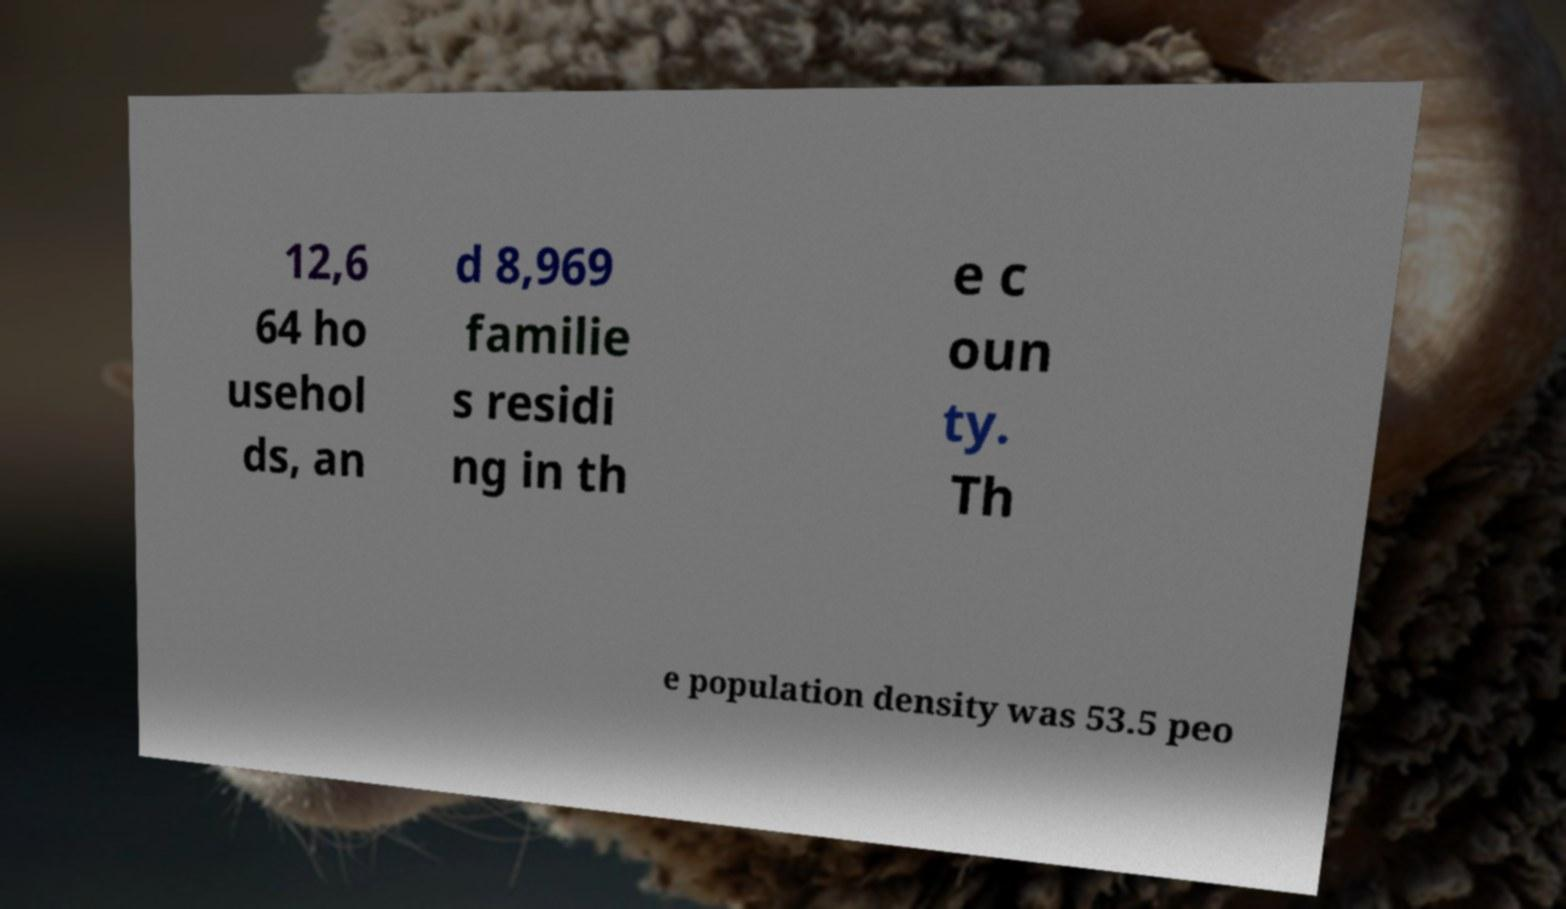Please read and relay the text visible in this image. What does it say? 12,6 64 ho usehol ds, an d 8,969 familie s residi ng in th e c oun ty. Th e population density was 53.5 peo 